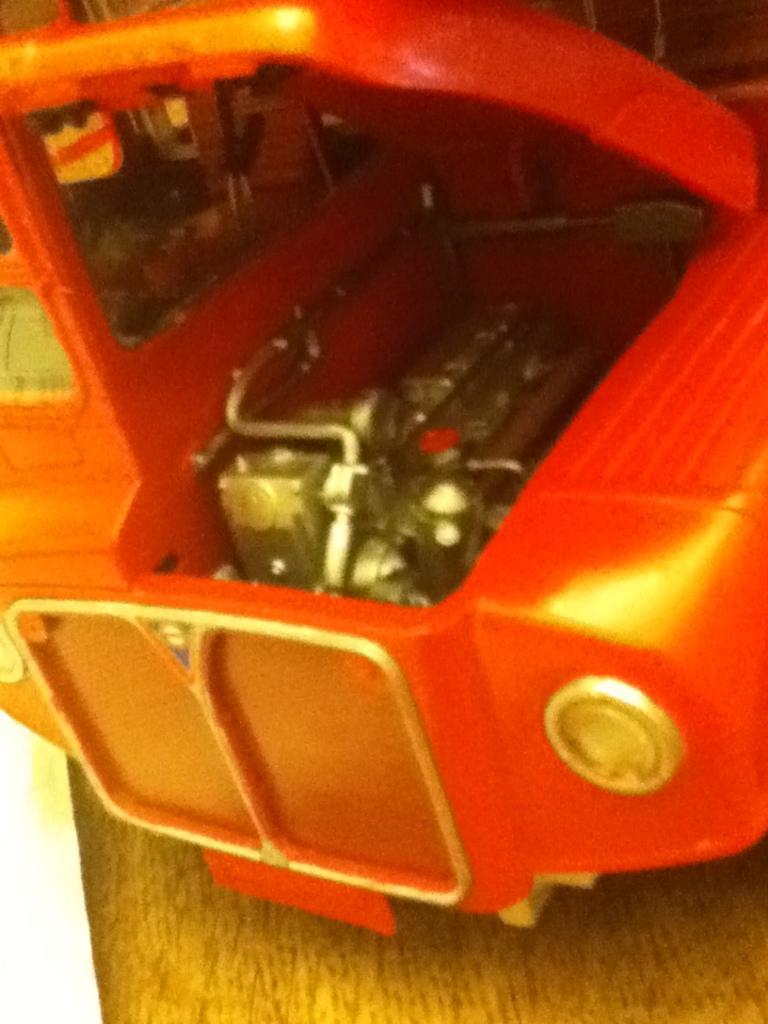Describe this image in one or two sentences. In this image we can see a toy which looks like a car in orange color and we can see some objects. 